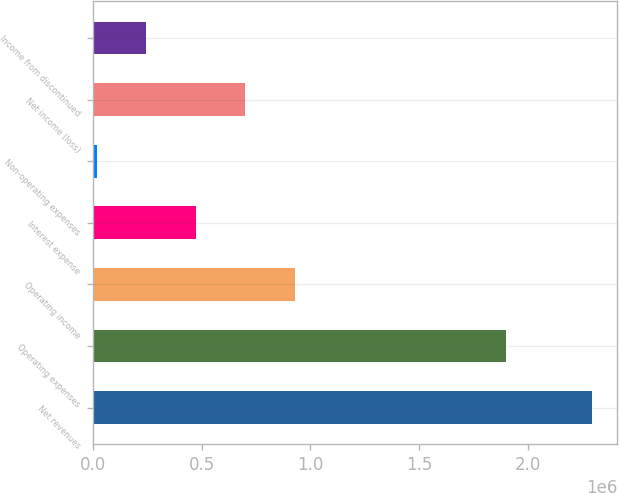Convert chart to OTSL. <chart><loc_0><loc_0><loc_500><loc_500><bar_chart><fcel>Net revenues<fcel>Operating expenses<fcel>Operating income<fcel>Interest expense<fcel>Non-operating expenses<fcel>Net income (loss)<fcel>Income from discontinued<nl><fcel>2.29818e+06<fcel>1.90104e+06<fcel>928237<fcel>471589<fcel>14942<fcel>699913<fcel>243266<nl></chart> 